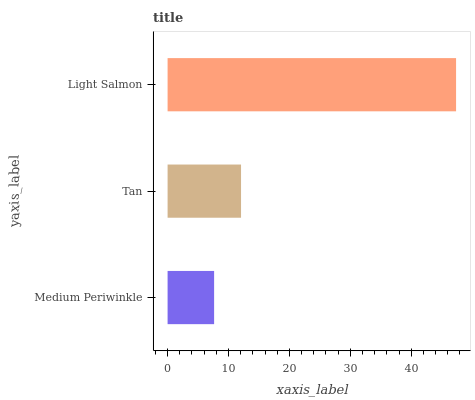Is Medium Periwinkle the minimum?
Answer yes or no. Yes. Is Light Salmon the maximum?
Answer yes or no. Yes. Is Tan the minimum?
Answer yes or no. No. Is Tan the maximum?
Answer yes or no. No. Is Tan greater than Medium Periwinkle?
Answer yes or no. Yes. Is Medium Periwinkle less than Tan?
Answer yes or no. Yes. Is Medium Periwinkle greater than Tan?
Answer yes or no. No. Is Tan less than Medium Periwinkle?
Answer yes or no. No. Is Tan the high median?
Answer yes or no. Yes. Is Tan the low median?
Answer yes or no. Yes. Is Medium Periwinkle the high median?
Answer yes or no. No. Is Light Salmon the low median?
Answer yes or no. No. 